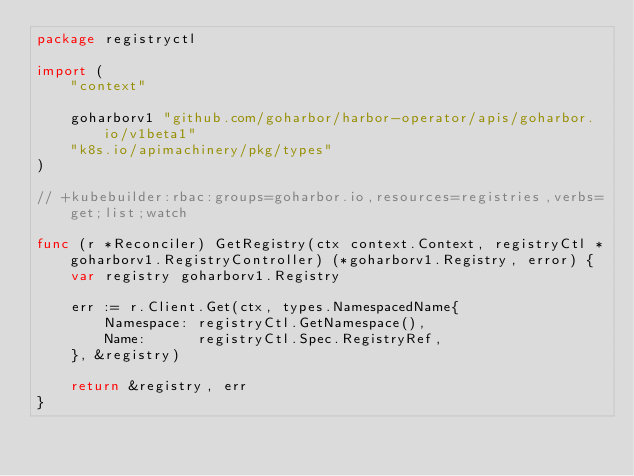Convert code to text. <code><loc_0><loc_0><loc_500><loc_500><_Go_>package registryctl

import (
	"context"

	goharborv1 "github.com/goharbor/harbor-operator/apis/goharbor.io/v1beta1"
	"k8s.io/apimachinery/pkg/types"
)

// +kubebuilder:rbac:groups=goharbor.io,resources=registries,verbs=get;list;watch

func (r *Reconciler) GetRegistry(ctx context.Context, registryCtl *goharborv1.RegistryController) (*goharborv1.Registry, error) {
	var registry goharborv1.Registry

	err := r.Client.Get(ctx, types.NamespacedName{
		Namespace: registryCtl.GetNamespace(),
		Name:      registryCtl.Spec.RegistryRef,
	}, &registry)

	return &registry, err
}
</code> 